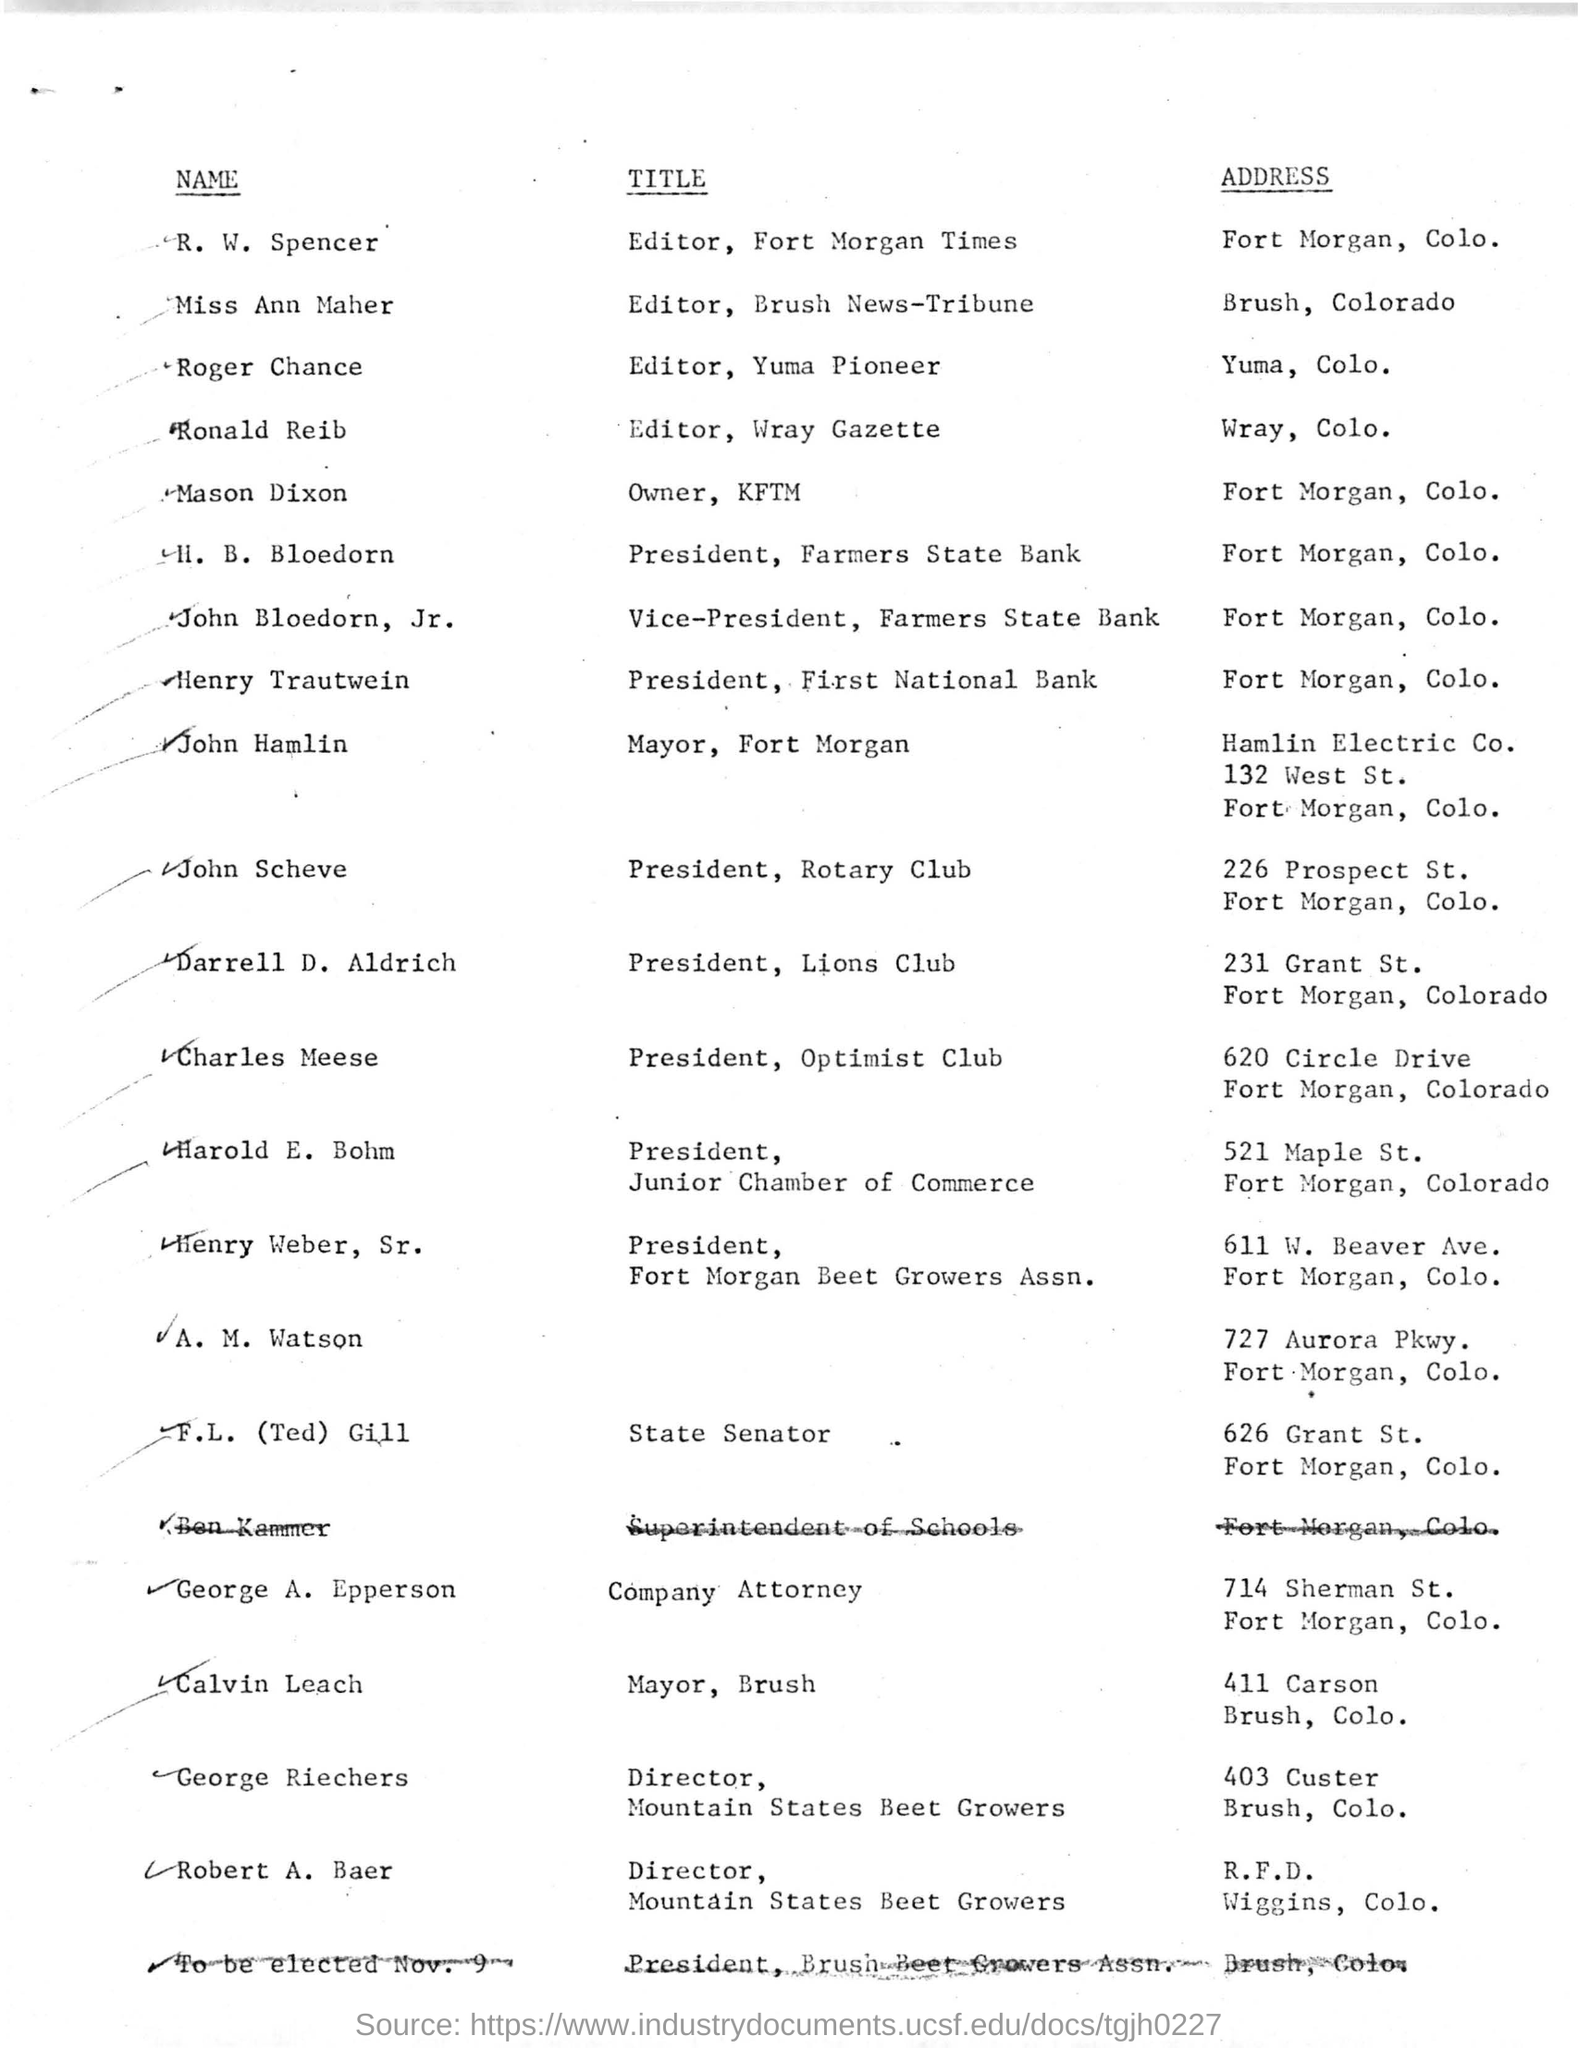Indicate a few pertinent items in this graphic. The name of the owner of 'Owner, KFTM' is Mason Dixon. R.W. Spencer is the editor of the Fort Morgan Times and holds the title of Editor. Henry Trautwein resides in Fort Morgan, Colorado. John Hamlin is the mayor of Fort Morgan. Roger Chance is the editor of Yuma Pioneer and his title is "Editor, Yuma Pioneer". 